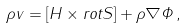Convert formula to latex. <formula><loc_0><loc_0><loc_500><loc_500>\rho { v } = [ { H } \times r o t { S } ] + \rho \nabla \Phi \, ,</formula> 